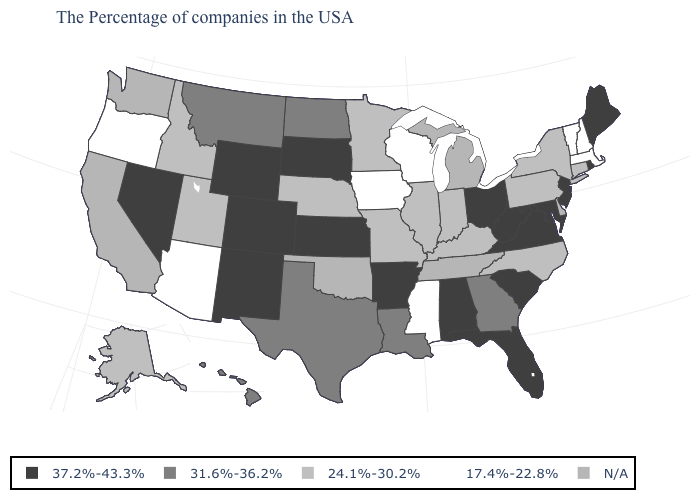How many symbols are there in the legend?
Be succinct. 5. What is the value of Connecticut?
Write a very short answer. 24.1%-30.2%. What is the value of South Dakota?
Concise answer only. 37.2%-43.3%. What is the value of Ohio?
Give a very brief answer. 37.2%-43.3%. How many symbols are there in the legend?
Quick response, please. 5. Does Virginia have the highest value in the USA?
Quick response, please. Yes. Among the states that border Oregon , which have the highest value?
Write a very short answer. Nevada. What is the value of Virginia?
Write a very short answer. 37.2%-43.3%. What is the lowest value in states that border Oregon?
Keep it brief. 24.1%-30.2%. Does Iowa have the lowest value in the USA?
Quick response, please. Yes. What is the lowest value in the USA?
Answer briefly. 17.4%-22.8%. What is the value of New Hampshire?
Concise answer only. 17.4%-22.8%. Which states have the highest value in the USA?
Keep it brief. Maine, Rhode Island, New Jersey, Maryland, Virginia, South Carolina, West Virginia, Ohio, Florida, Alabama, Arkansas, Kansas, South Dakota, Wyoming, Colorado, New Mexico, Nevada. Name the states that have a value in the range 24.1%-30.2%?
Concise answer only. Connecticut, New York, Pennsylvania, North Carolina, Kentucky, Indiana, Illinois, Missouri, Minnesota, Nebraska, Utah, Idaho, Alaska. 